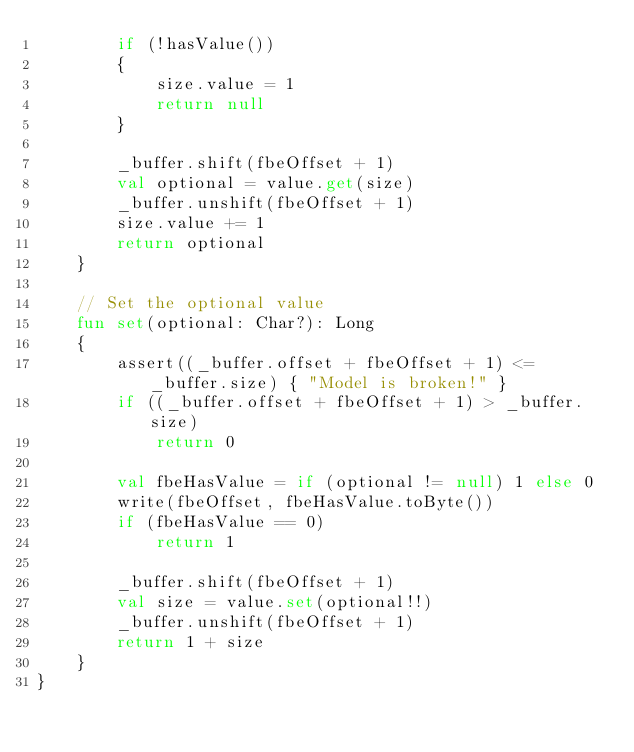Convert code to text. <code><loc_0><loc_0><loc_500><loc_500><_Kotlin_>        if (!hasValue())
        {
            size.value = 1
            return null
        }

        _buffer.shift(fbeOffset + 1)
        val optional = value.get(size)
        _buffer.unshift(fbeOffset + 1)
        size.value += 1
        return optional
    }

    // Set the optional value
    fun set(optional: Char?): Long
    {
        assert((_buffer.offset + fbeOffset + 1) <= _buffer.size) { "Model is broken!" }
        if ((_buffer.offset + fbeOffset + 1) > _buffer.size)
            return 0

        val fbeHasValue = if (optional != null) 1 else 0
        write(fbeOffset, fbeHasValue.toByte())
        if (fbeHasValue == 0)
            return 1

        _buffer.shift(fbeOffset + 1)
        val size = value.set(optional!!)
        _buffer.unshift(fbeOffset + 1)
        return 1 + size
    }
}
</code> 